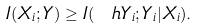Convert formula to latex. <formula><loc_0><loc_0><loc_500><loc_500>I ( X _ { i } ; Y ) \geq I ( \ h Y _ { i } ; Y _ { i } | X _ { i } ) .</formula> 